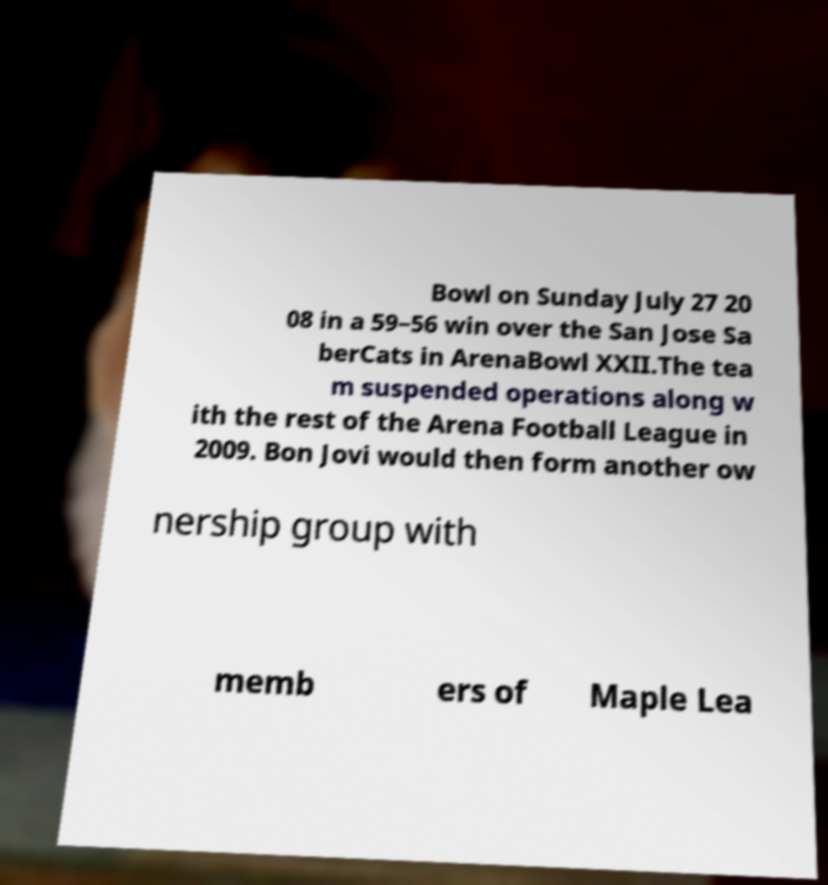Could you extract and type out the text from this image? Bowl on Sunday July 27 20 08 in a 59–56 win over the San Jose Sa berCats in ArenaBowl XXII.The tea m suspended operations along w ith the rest of the Arena Football League in 2009. Bon Jovi would then form another ow nership group with memb ers of Maple Lea 